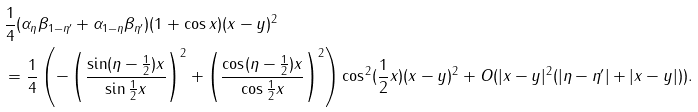<formula> <loc_0><loc_0><loc_500><loc_500>& \frac { 1 } { 4 } ( \alpha _ { \eta } \beta _ { 1 - \eta ^ { \prime } } + \alpha _ { 1 - \eta } \beta _ { \eta ^ { \prime } } ) ( 1 + \cos x ) ( x - y ) ^ { 2 } \\ & = \frac { 1 } { 4 } \left ( - \left ( \frac { \sin ( \eta - \frac { 1 } { 2 } ) x } { \sin \frac { 1 } { 2 } x } \right ) ^ { 2 } + \left ( \frac { \cos ( \eta - \frac { 1 } { 2 } ) x } { \cos \frac { 1 } { 2 } x } \right ) ^ { 2 } \right ) \cos ^ { 2 } ( \frac { 1 } { 2 } x ) ( x - y ) ^ { 2 } + O ( | x - y | ^ { 2 } ( | \eta - \eta ^ { \prime } | + | x - y | ) ) .</formula> 